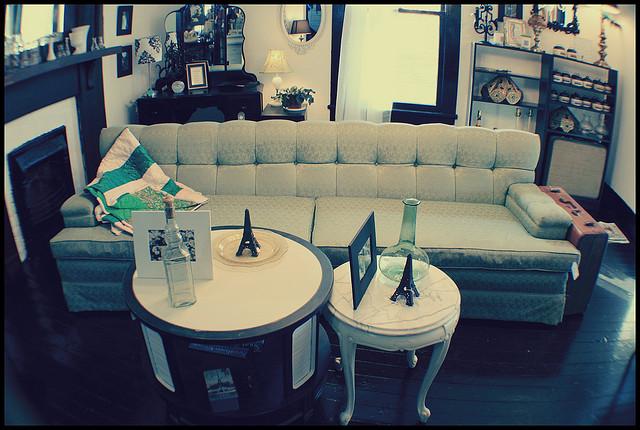What is in the bottle on the table?
Write a very short answer. Nothing. Was this picture taken from inside or outside?
Give a very brief answer. Inside. What color is the sofa?
Keep it brief. Gray. Did someone throw out this sofa?
Answer briefly. No. What vegetable does the sculpture on the right resemble?
Concise answer only. None. What color are the seats?
Short answer required. White. Is the fireplace lit?
Be succinct. No. How many red bottles are in the picture?
Answer briefly. 0. What National Monument is showcased on the tables?
Quick response, please. Eiffel tower. Is this scene in a private home?
Quick response, please. Yes. 